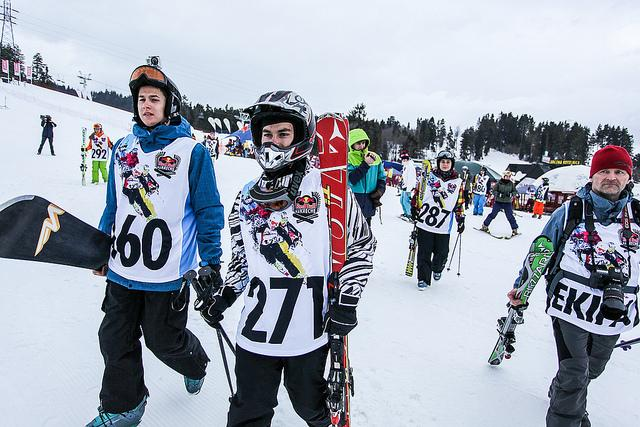WHat kind of competition is taking place? snowboarding 